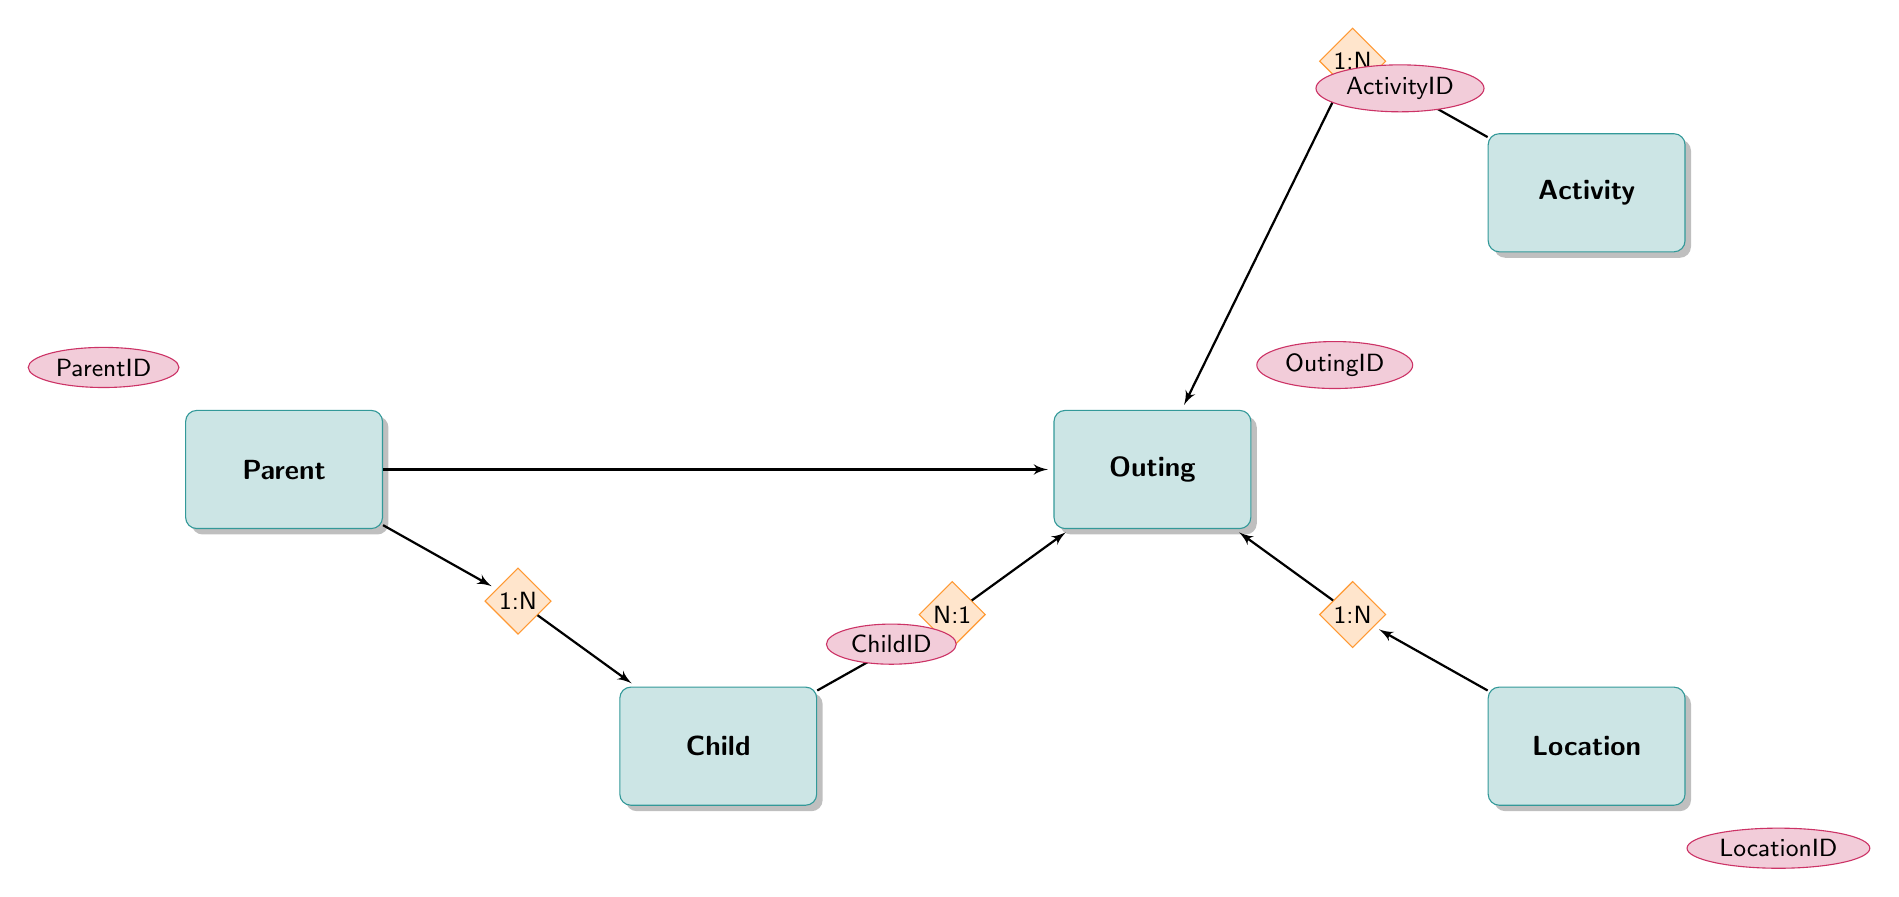What is the maximum number of children a parent can have? The relationship between Parent and Child is One to Many, which indicates that a single parent can have multiple children. The exact number is not specified in the diagram.
Answer: Many How many activities can be associated with a single outing? The relationship between Activity and Outing is One to Many, which shows that one activity can be connected to several outings.
Answer: Many Which entity has the attribute "PhoneNumber"? By examining the Parent entity, it is clear that the attributes included are ParentID, Name, and PhoneNumber. Therefore, PhoneNumber belongs to the Parent entity.
Answer: Parent What is the reference key for the Child entity? The Child entity includes an attribute listed as ChildID, which is its reference key in the relationships defined.
Answer: ChildID How many relationships does the Outing entity have? The Outing entity has four relationships, each connecting it to Parent, Child, Activity, and Location. Thus, the total number of relationships from the Outing entity is four.
Answer: Four Explain how a parent obtains outing information related to an activity. To get outing information for an activity, one would start at the Activity entity, identify the ActivityID, then trace the One to Many relationship to the Outing entity. Each outing linked to that ActivityID would provide the related outing information.
Answer: Through Outing What type of entity is "Location"? The "Location" entity is classified as an entity that represents physical places where outings occur, as indicated in the context of the diagram.
Answer: Entity How does the activity type impact outings? The relationship between Activity and Outing indicates that each outing is linked to one specific activity defined by the ActivityID. Therefore, the type of activity dictates which outings can occur, as outings are organized based on specific activities selected from the available activities.
Answer: Activity Type impacts outings through selection 